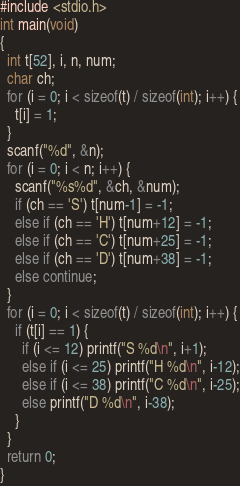<code> <loc_0><loc_0><loc_500><loc_500><_C_>#include <stdio.h>
int main(void)
{
  int t[52], i, n, num;
  char ch;
  for (i = 0; i < sizeof(t) / sizeof(int); i++) {
    t[i] = 1;
  }
  scanf("%d", &n);
  for (i = 0; i < n; i++) {
    scanf("%s%d", &ch, &num);
    if (ch == 'S') t[num-1] = -1; 
    else if (ch == 'H') t[num+12] = -1;
    else if (ch == 'C') t[num+25] = -1;
    else if (ch == 'D') t[num+38] = -1;
    else continue;
  }
  for (i = 0; i < sizeof(t) / sizeof(int); i++) {
    if (t[i] == 1) {
      if (i <= 12) printf("S %d\n", i+1);
      else if (i <= 25) printf("H %d\n", i-12);
      else if (i <= 38) printf("C %d\n", i-25);
      else printf("D %d\n", i-38);
    }
  }
  return 0;
}</code> 